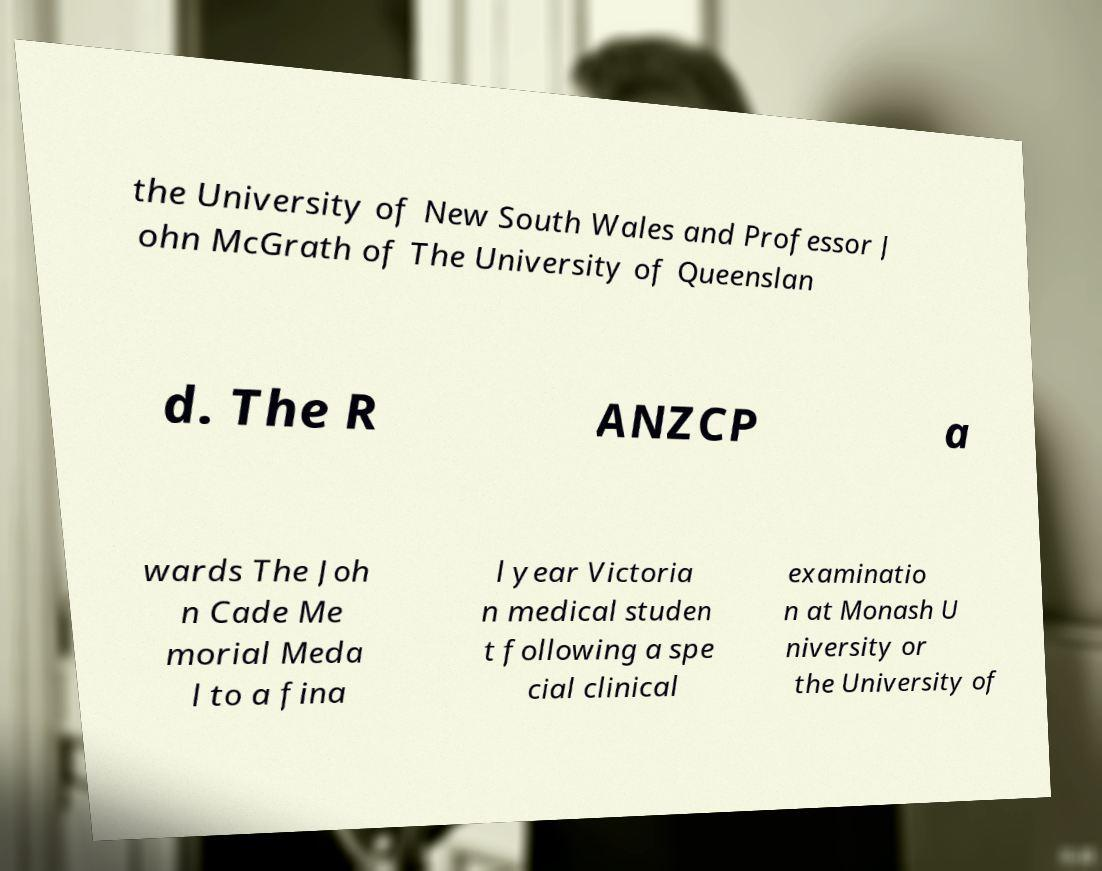I need the written content from this picture converted into text. Can you do that? the University of New South Wales and Professor J ohn McGrath of The University of Queenslan d. The R ANZCP a wards The Joh n Cade Me morial Meda l to a fina l year Victoria n medical studen t following a spe cial clinical examinatio n at Monash U niversity or the University of 